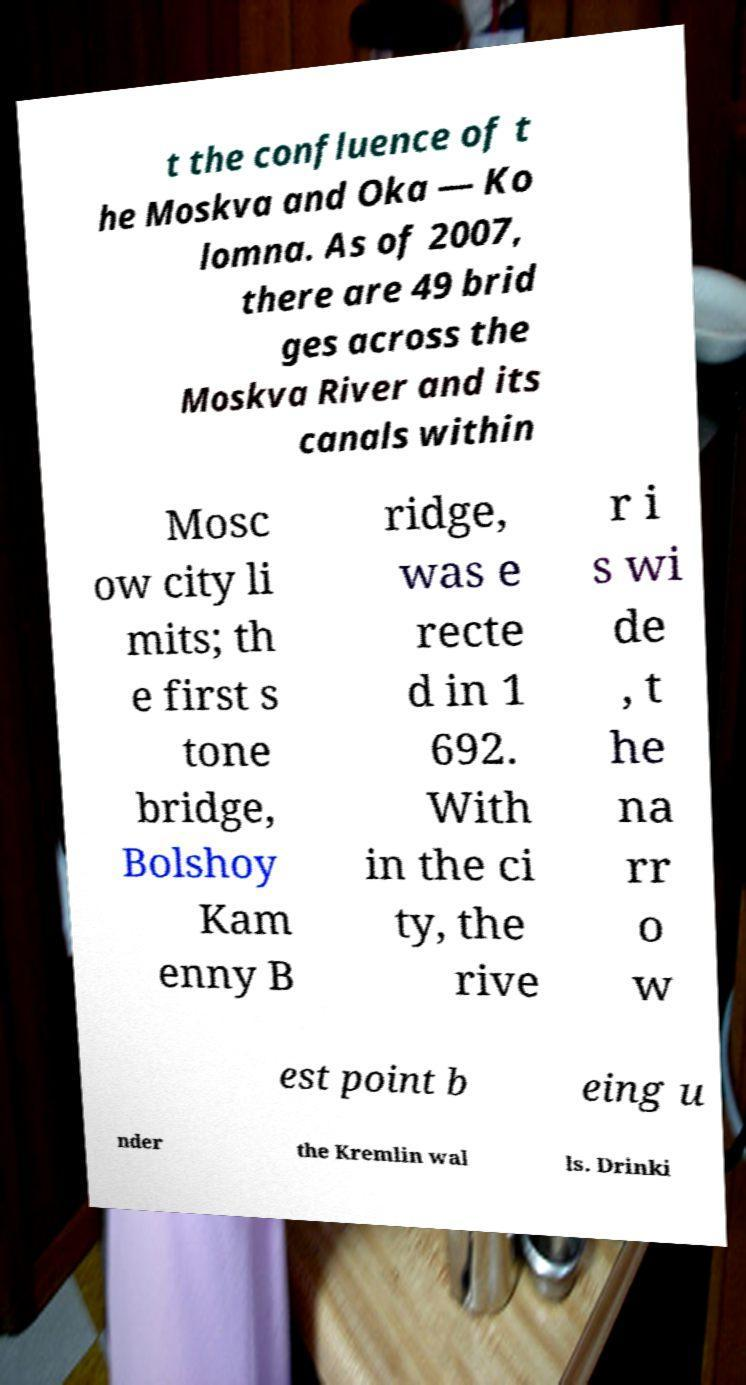Can you read and provide the text displayed in the image?This photo seems to have some interesting text. Can you extract and type it out for me? t the confluence of t he Moskva and Oka — Ko lomna. As of 2007, there are 49 brid ges across the Moskva River and its canals within Mosc ow city li mits; th e first s tone bridge, Bolshoy Kam enny B ridge, was e recte d in 1 692. With in the ci ty, the rive r i s wi de , t he na rr o w est point b eing u nder the Kremlin wal ls. Drinki 